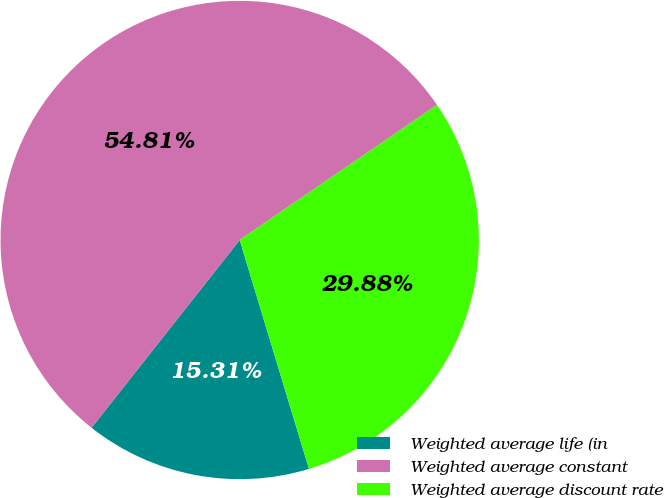Convert chart. <chart><loc_0><loc_0><loc_500><loc_500><pie_chart><fcel>Weighted average life (in<fcel>Weighted average constant<fcel>Weighted average discount rate<nl><fcel>15.31%<fcel>54.81%<fcel>29.88%<nl></chart> 